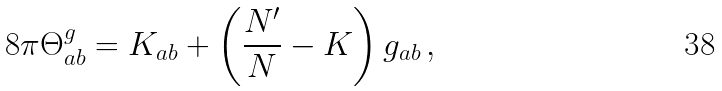Convert formula to latex. <formula><loc_0><loc_0><loc_500><loc_500>8 \pi \Theta _ { a b } ^ { g } = K _ { a b } + \left ( \frac { N ^ { \prime } } { N } - K \right ) g _ { a b } \, ,</formula> 